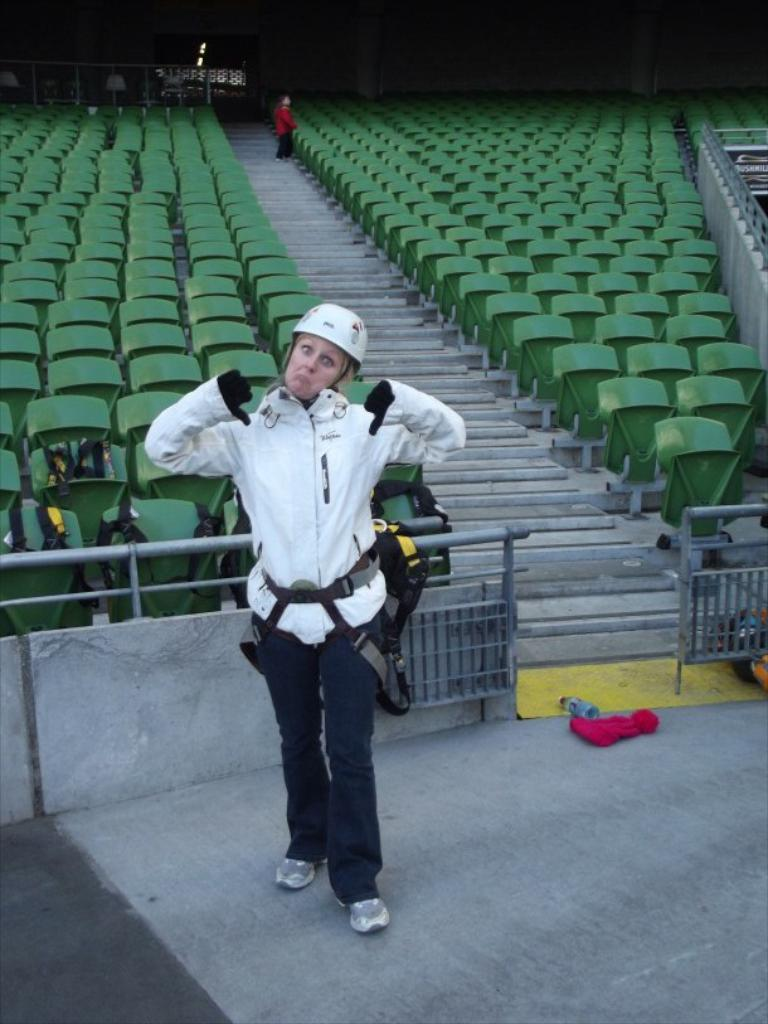What is the main subject of the image? There is a person standing in the image. Where is the person standing? The person is standing on the floor. What type of furniture can be seen in the image? There are stare cases and chairs visible in the image. How many apples are on the island in the image? There is no island or apples present in the image. What type of slip is the person wearing in the image? The image does not show the person's footwear, so it cannot be determined if they are wearing a slip or any other type of footwear. 